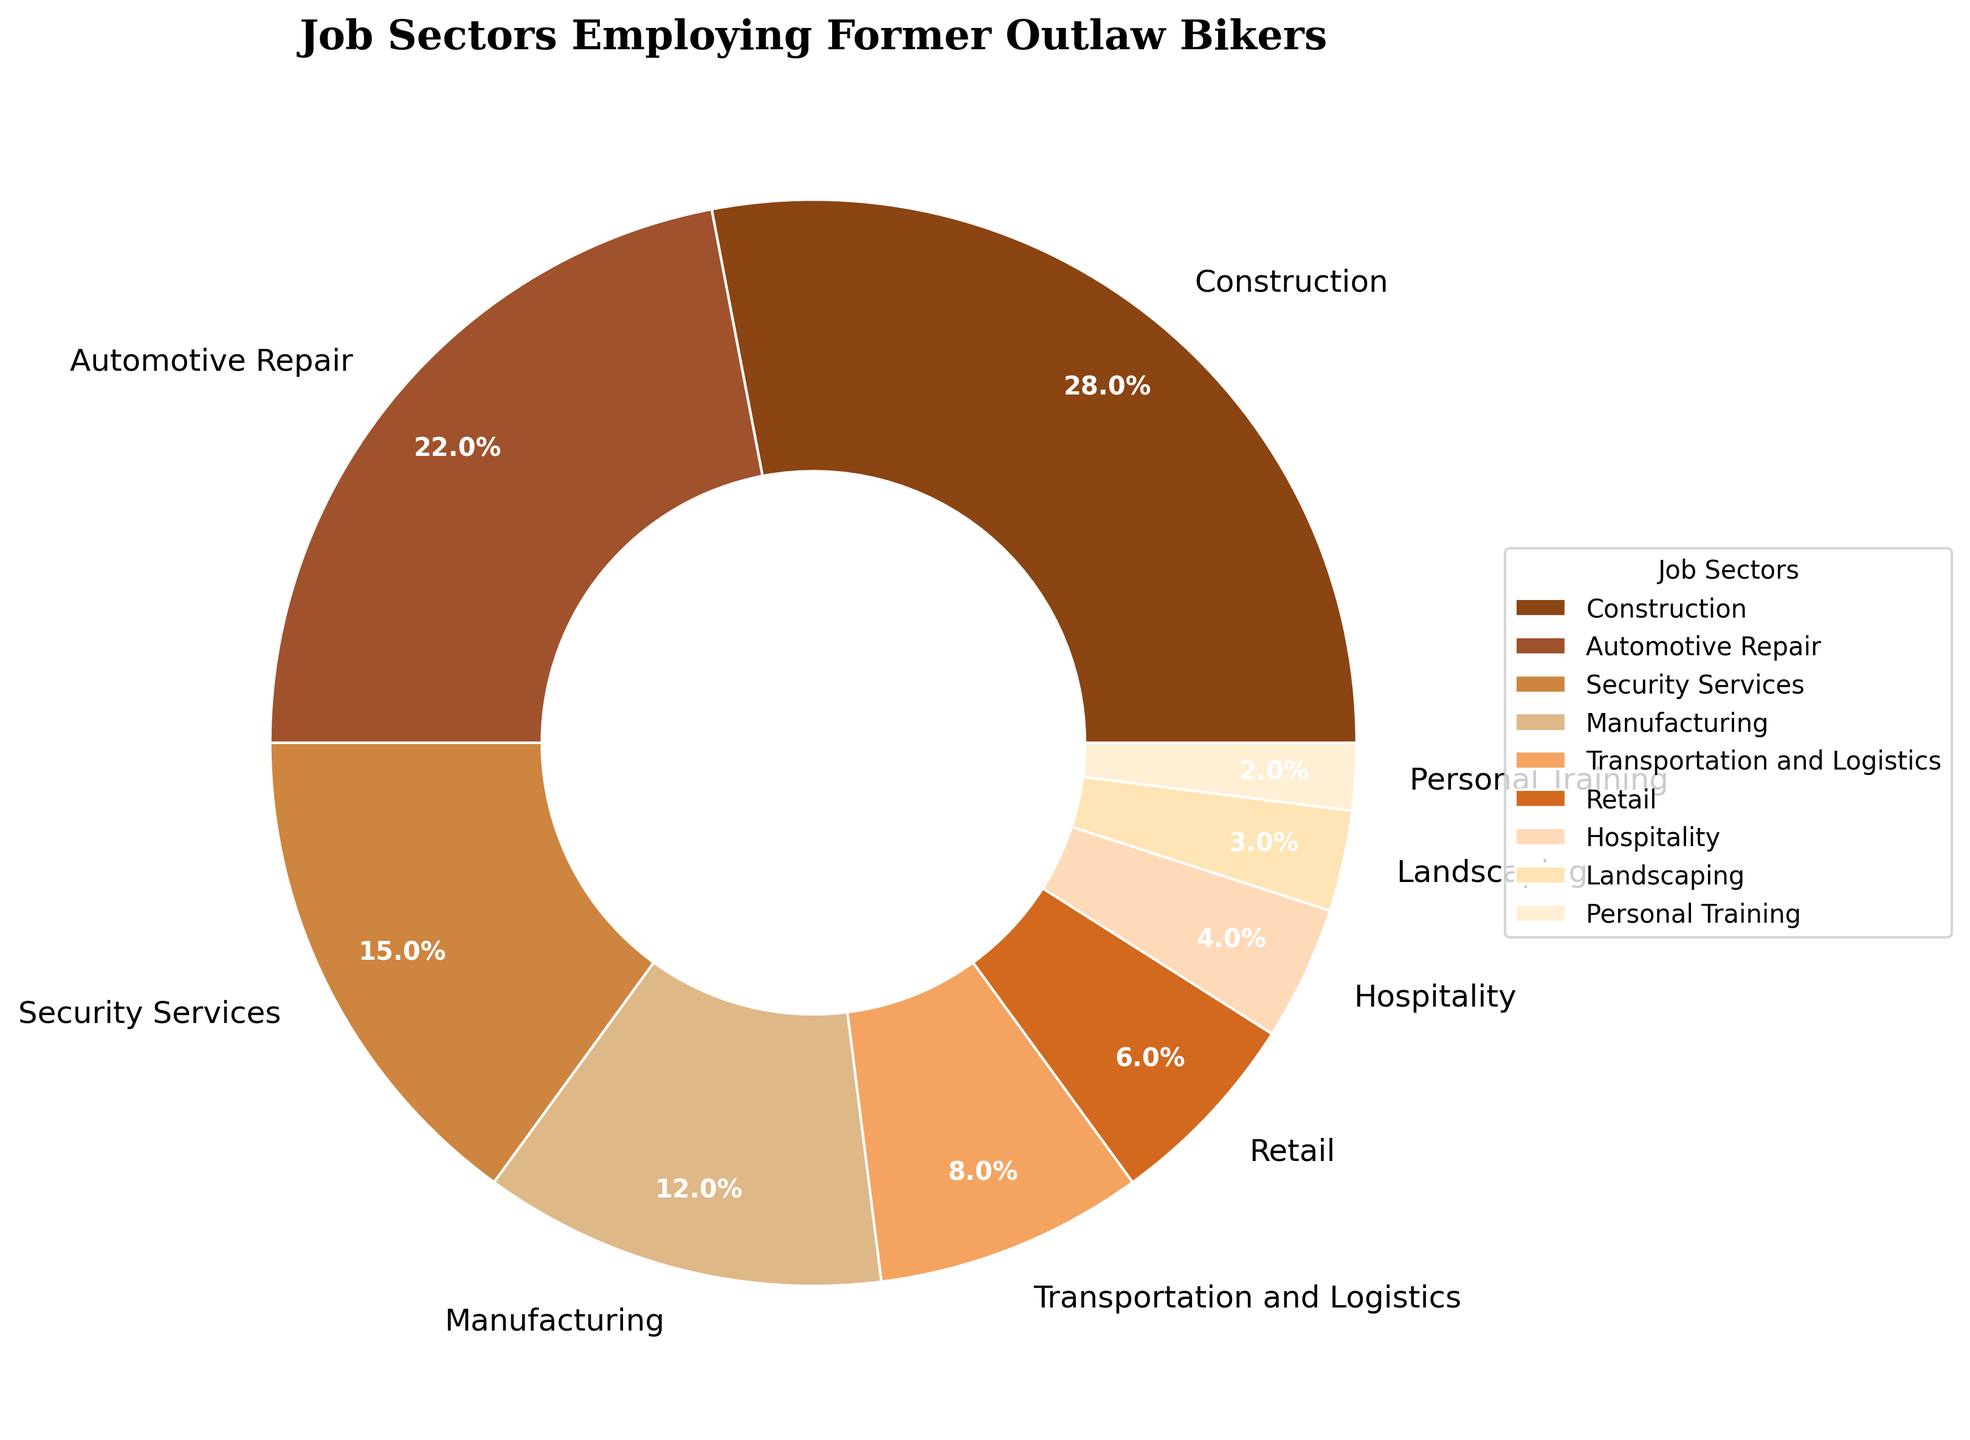What is the largest job sector employing former outlaw bikers according to the pie chart? The largest sector can be identified by looking at the section of the pie chart with the largest slice. Construction has the largest portion on the pie chart.
Answer: Construction What percentage of former outlaw bikers are employed in both Manufacturing and Transportation and Logistics combined? Add the percentages of both Manufacturing (12%) and Transportation and Logistics (8%) together, which gives 12% + 8% = 20%.
Answer: 20% Which job sector employs fewer former outlaw bikers, Hospitality or Landscaping? Compare the slices representing Hospitality and Landscaping. Hospitality has 4% and Landscaping has 3%. Since 3% is less than 4%, Landscaping employs fewer former outlaw bikers.
Answer: Landscaping Between Security Services and Retail, which sector employs a higher percentage of former outlaw bikers? Look at the respective slices; Security Services shows 15% and Retail shows 6%. Since 15% is greater than 6%, Security Services employs a higher percentage.
Answer: Security Services What is the difference in percentage between the Automotive Repair sector and the Hospitality sector? Subtract the percentage of Hospitality (4%) from Automotive Repair (22%) to get the difference: 22% - 4% = 18%.
Answer: 18% How many job sectors employ less than 5% of former outlaw bikers? Identify slices that represent proportions under 5%: Landscaping (3%), and Personal Training (2%). That makes 2 sectors.
Answer: 2 If you sum up the percentages of the two smallest sectors, what value do you get? Add the percentages of the two smallest sectors, which are Landscaping (3%) and Personal Training (2%): 3% + 2% = 5%.
Answer: 5% Which job sector has a wedge colored in a hue reminiscent of wood or leather, but employs less than 10% of former outlaw bikers? Review the colors used in the pie chart, focusing on earthy hues, then find sectors under 10%. Transportation and Logistics (8%) fits this description with a brownish hue.
Answer: Transportation and Logistics What is the total percentage of former outlaw bikers employed in Automotive Repair and Security Services? Add the percentages of Automotive Repair (22%) and Security Services (15%) together: 22% + 15% = 37%.
Answer: 37% If 1000 former outlaw bikers were surveyed, how many of them would be working in the Construction sector? Calculate the number based on the percentage for Construction (28%): 1000 * 0.28 = 280.
Answer: 280 